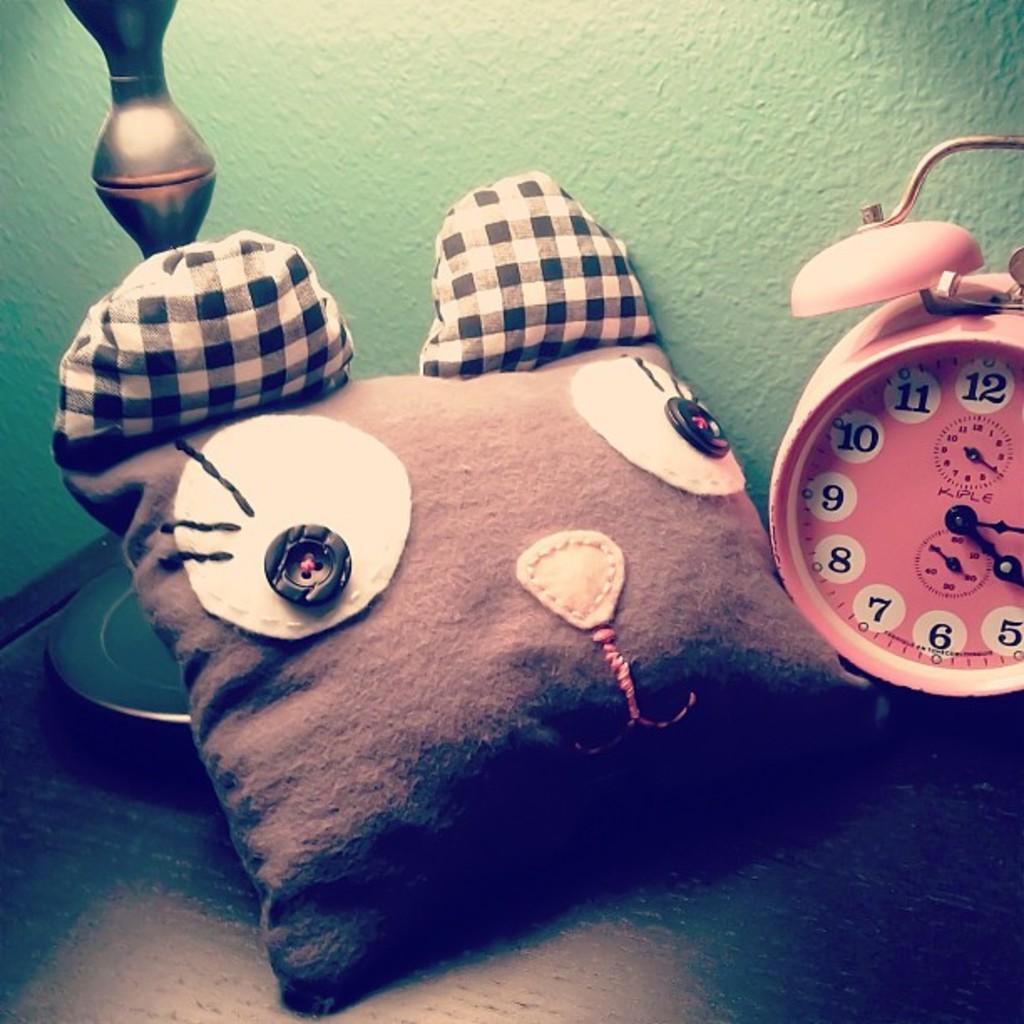<image>
Create a compact narrative representing the image presented. A clock has two small clocks on the face and the top one has both hands pointing at the four. 